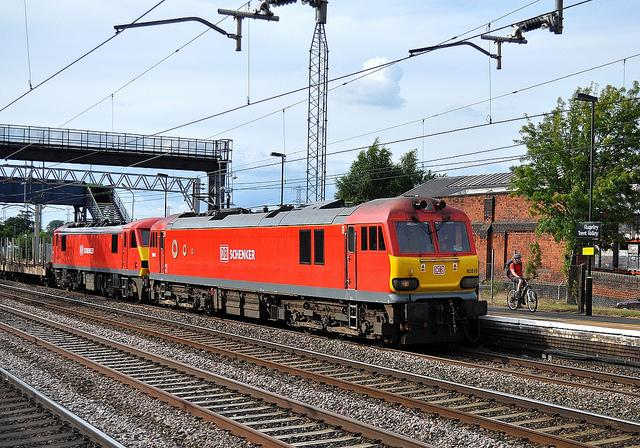Why has the cyclist covered his head?

Choices:
A) safety
B) fashion
C) warmth
D) religion safety 